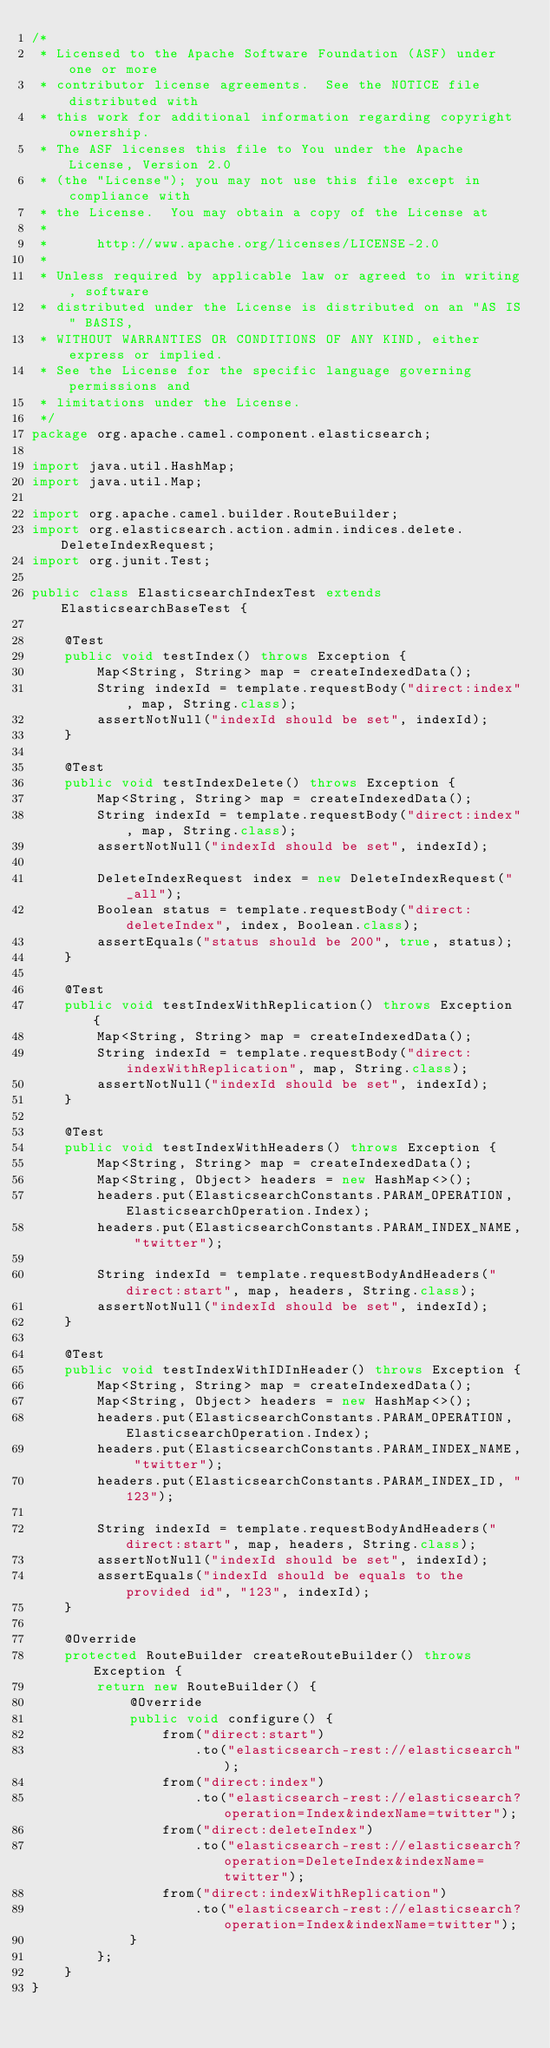Convert code to text. <code><loc_0><loc_0><loc_500><loc_500><_Java_>/*
 * Licensed to the Apache Software Foundation (ASF) under one or more
 * contributor license agreements.  See the NOTICE file distributed with
 * this work for additional information regarding copyright ownership.
 * The ASF licenses this file to You under the Apache License, Version 2.0
 * (the "License"); you may not use this file except in compliance with
 * the License.  You may obtain a copy of the License at
 *
 *      http://www.apache.org/licenses/LICENSE-2.0
 *
 * Unless required by applicable law or agreed to in writing, software
 * distributed under the License is distributed on an "AS IS" BASIS,
 * WITHOUT WARRANTIES OR CONDITIONS OF ANY KIND, either express or implied.
 * See the License for the specific language governing permissions and
 * limitations under the License.
 */
package org.apache.camel.component.elasticsearch;

import java.util.HashMap;
import java.util.Map;

import org.apache.camel.builder.RouteBuilder;
import org.elasticsearch.action.admin.indices.delete.DeleteIndexRequest;
import org.junit.Test;

public class ElasticsearchIndexTest extends ElasticsearchBaseTest {

    @Test
    public void testIndex() throws Exception {
        Map<String, String> map = createIndexedData();
        String indexId = template.requestBody("direct:index", map, String.class);
        assertNotNull("indexId should be set", indexId);
    }

    @Test
    public void testIndexDelete() throws Exception {
        Map<String, String> map = createIndexedData();
        String indexId = template.requestBody("direct:index", map, String.class);
        assertNotNull("indexId should be set", indexId);

        DeleteIndexRequest index = new DeleteIndexRequest("_all");
        Boolean status = template.requestBody("direct:deleteIndex", index, Boolean.class);
        assertEquals("status should be 200", true, status);
    }

    @Test
    public void testIndexWithReplication() throws Exception {
        Map<String, String> map = createIndexedData();
        String indexId = template.requestBody("direct:indexWithReplication", map, String.class);
        assertNotNull("indexId should be set", indexId);
    }

    @Test
    public void testIndexWithHeaders() throws Exception {
        Map<String, String> map = createIndexedData();
        Map<String, Object> headers = new HashMap<>();
        headers.put(ElasticsearchConstants.PARAM_OPERATION, ElasticsearchOperation.Index);
        headers.put(ElasticsearchConstants.PARAM_INDEX_NAME, "twitter");

        String indexId = template.requestBodyAndHeaders("direct:start", map, headers, String.class);
        assertNotNull("indexId should be set", indexId);
    }

    @Test
    public void testIndexWithIDInHeader() throws Exception {
        Map<String, String> map = createIndexedData();
        Map<String, Object> headers = new HashMap<>();
        headers.put(ElasticsearchConstants.PARAM_OPERATION, ElasticsearchOperation.Index);
        headers.put(ElasticsearchConstants.PARAM_INDEX_NAME, "twitter");
        headers.put(ElasticsearchConstants.PARAM_INDEX_ID, "123");

        String indexId = template.requestBodyAndHeaders("direct:start", map, headers, String.class);
        assertNotNull("indexId should be set", indexId);
        assertEquals("indexId should be equals to the provided id", "123", indexId);
    }

    @Override
    protected RouteBuilder createRouteBuilder() throws Exception {
        return new RouteBuilder() {
            @Override
            public void configure() {
                from("direct:start")
                    .to("elasticsearch-rest://elasticsearch");
                from("direct:index")
                    .to("elasticsearch-rest://elasticsearch?operation=Index&indexName=twitter");
                from("direct:deleteIndex")
                    .to("elasticsearch-rest://elasticsearch?operation=DeleteIndex&indexName=twitter");
                from("direct:indexWithReplication")
                    .to("elasticsearch-rest://elasticsearch?operation=Index&indexName=twitter");
            }
        };
    }
}
</code> 